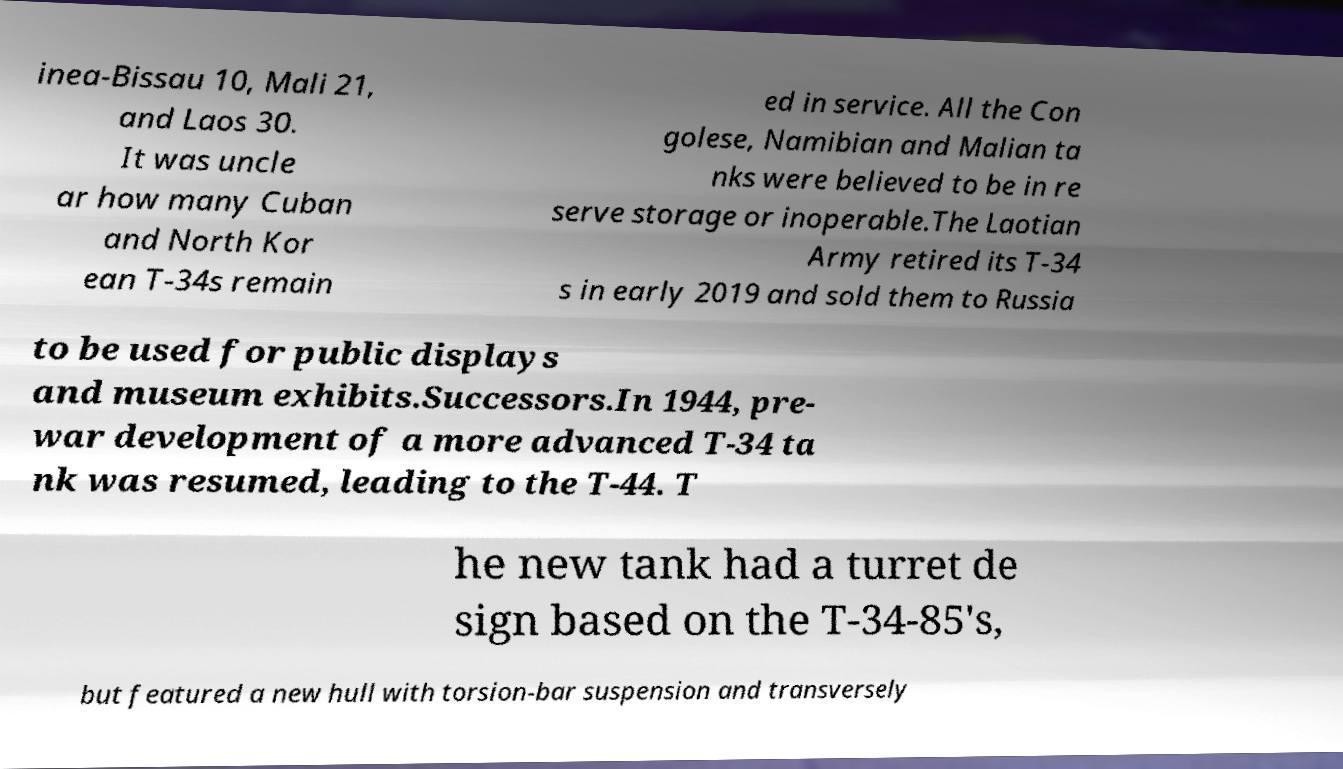Can you accurately transcribe the text from the provided image for me? inea-Bissau 10, Mali 21, and Laos 30. It was uncle ar how many Cuban and North Kor ean T-34s remain ed in service. All the Con golese, Namibian and Malian ta nks were believed to be in re serve storage or inoperable.The Laotian Army retired its T-34 s in early 2019 and sold them to Russia to be used for public displays and museum exhibits.Successors.In 1944, pre- war development of a more advanced T-34 ta nk was resumed, leading to the T-44. T he new tank had a turret de sign based on the T-34-85's, but featured a new hull with torsion-bar suspension and transversely 